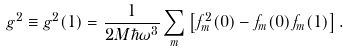<formula> <loc_0><loc_0><loc_500><loc_500>g ^ { 2 } \equiv g ^ { 2 } ( 1 ) = \frac { 1 } { 2 M \hbar { \omega } ^ { 3 } } \sum _ { m } \left [ f ^ { 2 } _ { m } ( 0 ) - f _ { m } ( 0 ) f _ { m } ( 1 ) \right ] .</formula> 